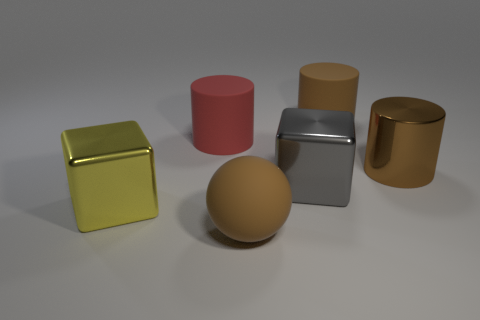Add 2 large brown rubber things. How many objects exist? 8 Subtract all spheres. How many objects are left? 5 Add 1 large rubber cylinders. How many large rubber cylinders exist? 3 Subtract 1 gray blocks. How many objects are left? 5 Subtract all big cyan shiny cylinders. Subtract all gray blocks. How many objects are left? 5 Add 1 red matte cylinders. How many red matte cylinders are left? 2 